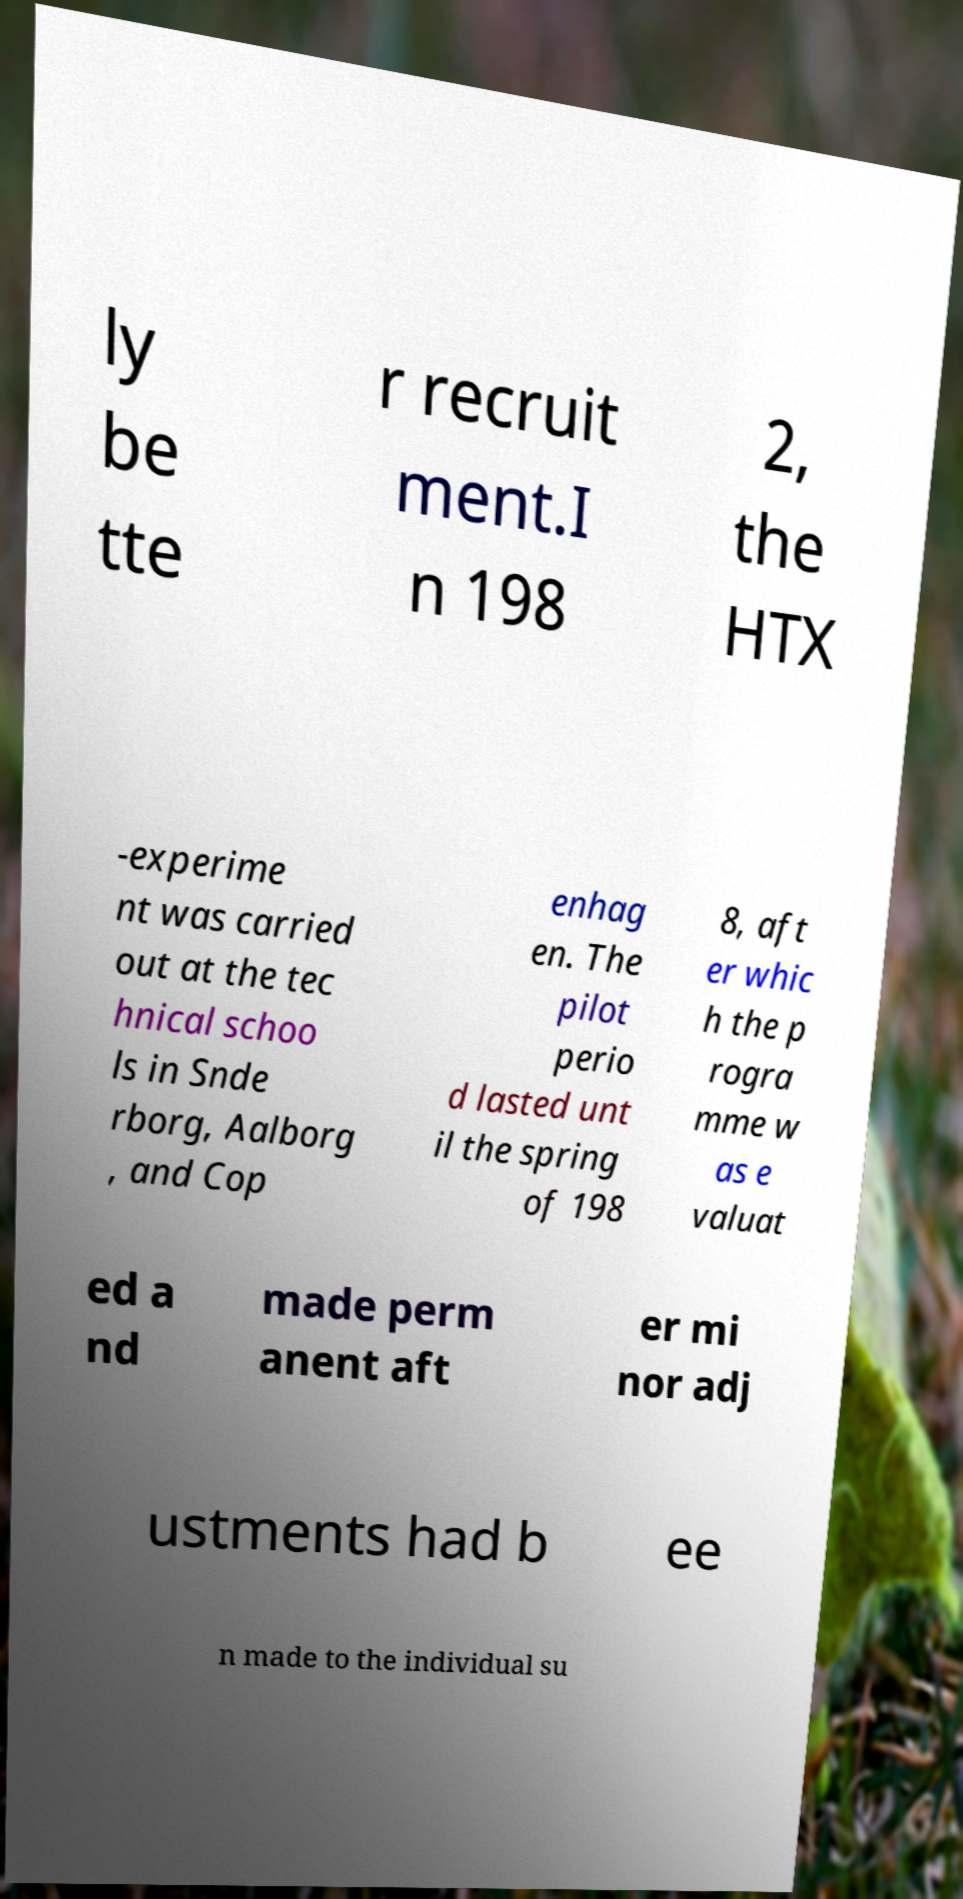Please identify and transcribe the text found in this image. ly be tte r recruit ment.I n 198 2, the HTX -experime nt was carried out at the tec hnical schoo ls in Snde rborg, Aalborg , and Cop enhag en. The pilot perio d lasted unt il the spring of 198 8, aft er whic h the p rogra mme w as e valuat ed a nd made perm anent aft er mi nor adj ustments had b ee n made to the individual su 